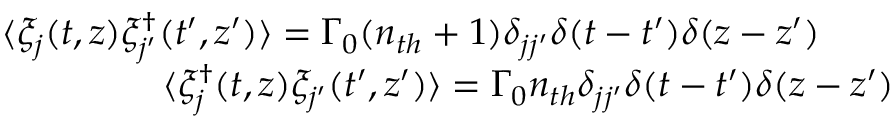<formula> <loc_0><loc_0><loc_500><loc_500>\begin{array} { r l r } & { \langle \xi _ { j } ( t , z ) \xi _ { j ^ { \prime } } ^ { \dag } ( t ^ { \prime } , z ^ { \prime } ) \rangle = \Gamma _ { 0 } ( n _ { t h } + 1 ) \delta _ { j j ^ { \prime } } \delta ( t - t ^ { \prime } ) \delta ( z - z ^ { \prime } ) \quad } \\ & { \langle \xi _ { j } ^ { \dag } ( t , z ) \xi _ { j ^ { \prime } } ( t ^ { \prime } , z ^ { \prime } ) \rangle = \Gamma _ { 0 } n _ { t h } \delta _ { j j ^ { \prime } } \delta ( t - t ^ { \prime } ) \delta ( z - z ^ { \prime } ) } \end{array}</formula> 